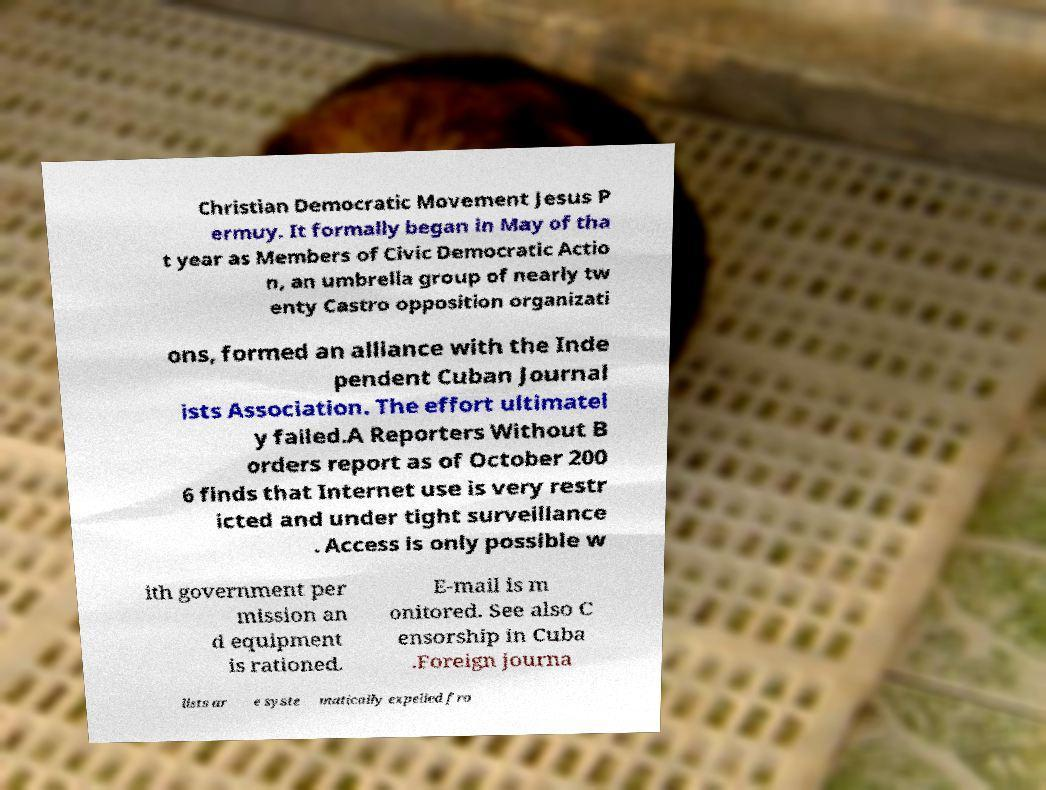I need the written content from this picture converted into text. Can you do that? Christian Democratic Movement Jesus P ermuy. It formally began in May of tha t year as Members of Civic Democratic Actio n, an umbrella group of nearly tw enty Castro opposition organizati ons, formed an alliance with the Inde pendent Cuban Journal ists Association. The effort ultimatel y failed.A Reporters Without B orders report as of October 200 6 finds that Internet use is very restr icted and under tight surveillance . Access is only possible w ith government per mission an d equipment is rationed. E-mail is m onitored. See also C ensorship in Cuba .Foreign journa lists ar e syste matically expelled fro 